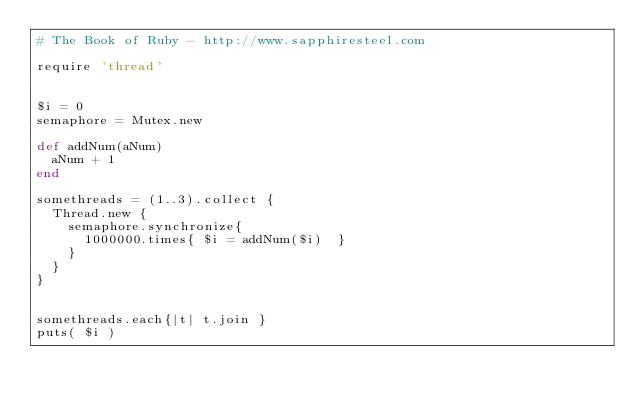Convert code to text. <code><loc_0><loc_0><loc_500><loc_500><_Ruby_># The Book of Ruby - http://www.sapphiresteel.com

require 'thread'


$i = 0
semaphore = Mutex.new

def addNum(aNum)
	aNum + 1
end

somethreads = (1..3).collect {
	Thread.new {
		semaphore.synchronize{
			1000000.times{ $i = addNum($i)  }
		}
	}
}


somethreads.each{|t| t.join } 
puts( $i )</code> 